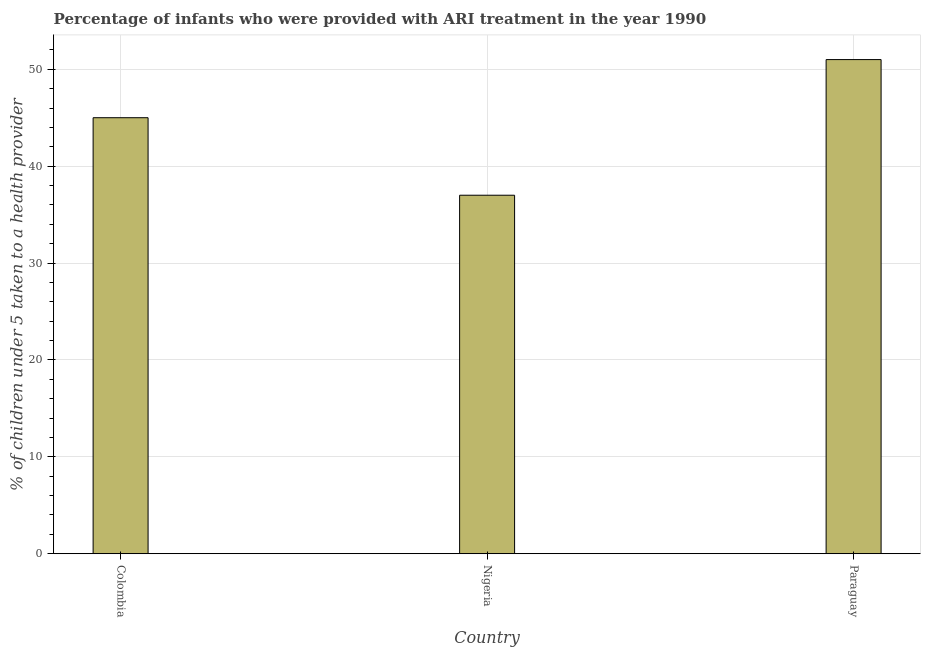Does the graph contain any zero values?
Provide a succinct answer. No. Does the graph contain grids?
Give a very brief answer. Yes. What is the title of the graph?
Offer a terse response. Percentage of infants who were provided with ARI treatment in the year 1990. What is the label or title of the Y-axis?
Provide a short and direct response. % of children under 5 taken to a health provider. What is the percentage of children who were provided with ari treatment in Paraguay?
Your response must be concise. 51. Across all countries, what is the maximum percentage of children who were provided with ari treatment?
Provide a short and direct response. 51. Across all countries, what is the minimum percentage of children who were provided with ari treatment?
Ensure brevity in your answer.  37. In which country was the percentage of children who were provided with ari treatment maximum?
Provide a short and direct response. Paraguay. In which country was the percentage of children who were provided with ari treatment minimum?
Offer a very short reply. Nigeria. What is the sum of the percentage of children who were provided with ari treatment?
Your answer should be compact. 133. What is the difference between the percentage of children who were provided with ari treatment in Colombia and Nigeria?
Provide a short and direct response. 8. What is the ratio of the percentage of children who were provided with ari treatment in Nigeria to that in Paraguay?
Your answer should be compact. 0.72. What is the difference between the highest and the second highest percentage of children who were provided with ari treatment?
Give a very brief answer. 6. In how many countries, is the percentage of children who were provided with ari treatment greater than the average percentage of children who were provided with ari treatment taken over all countries?
Keep it short and to the point. 2. How many bars are there?
Your response must be concise. 3. How many countries are there in the graph?
Provide a succinct answer. 3. What is the difference between two consecutive major ticks on the Y-axis?
Your response must be concise. 10. Are the values on the major ticks of Y-axis written in scientific E-notation?
Provide a succinct answer. No. What is the % of children under 5 taken to a health provider in Colombia?
Provide a succinct answer. 45. What is the difference between the % of children under 5 taken to a health provider in Colombia and Paraguay?
Your answer should be very brief. -6. What is the ratio of the % of children under 5 taken to a health provider in Colombia to that in Nigeria?
Your answer should be very brief. 1.22. What is the ratio of the % of children under 5 taken to a health provider in Colombia to that in Paraguay?
Offer a very short reply. 0.88. What is the ratio of the % of children under 5 taken to a health provider in Nigeria to that in Paraguay?
Your answer should be compact. 0.72. 